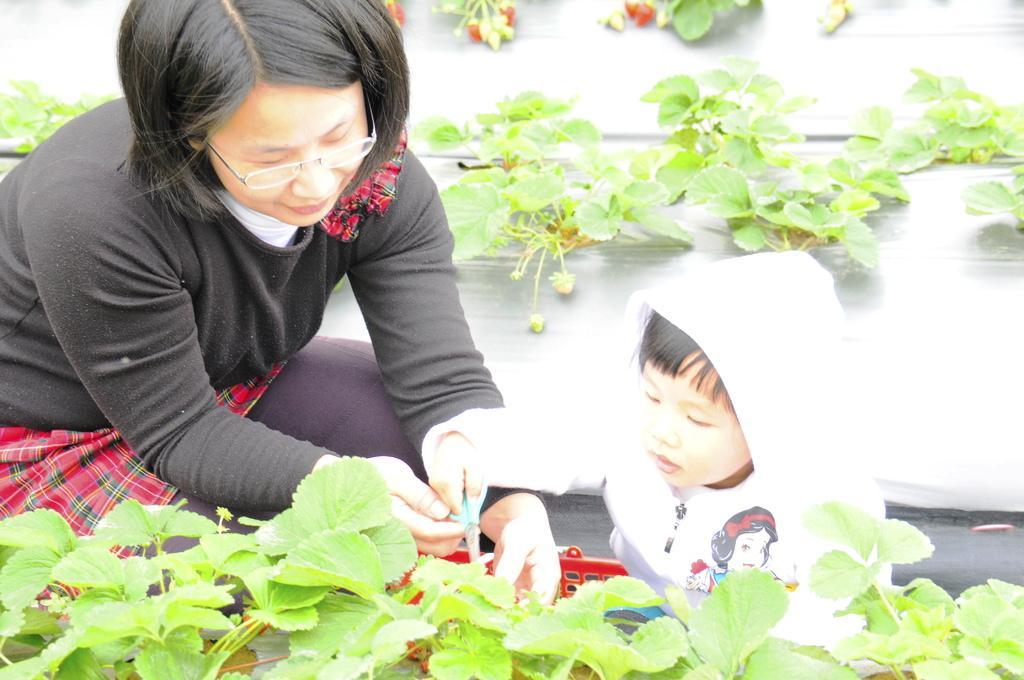Please provide a concise description of this image. In this image, we can see a woman and kid. They both are holding scissors. Here there is a basket. At the bottom and background we can see plants. 